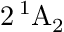Convert formula to latex. <formula><loc_0><loc_0><loc_500><loc_500>2 \, ^ { 1 } A _ { 2 }</formula> 